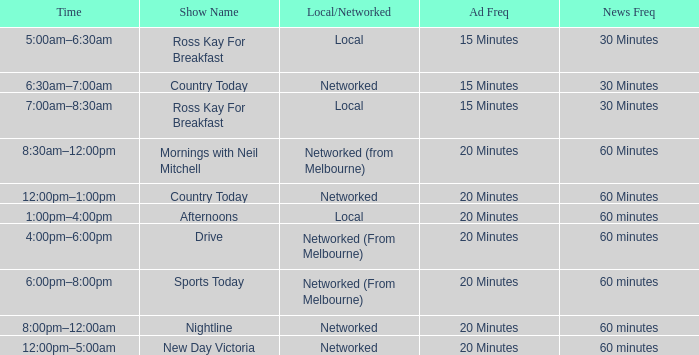What Ad Freq has a News Freq of 60 minutes, and a Local/Networked of local? 20 Minutes. 